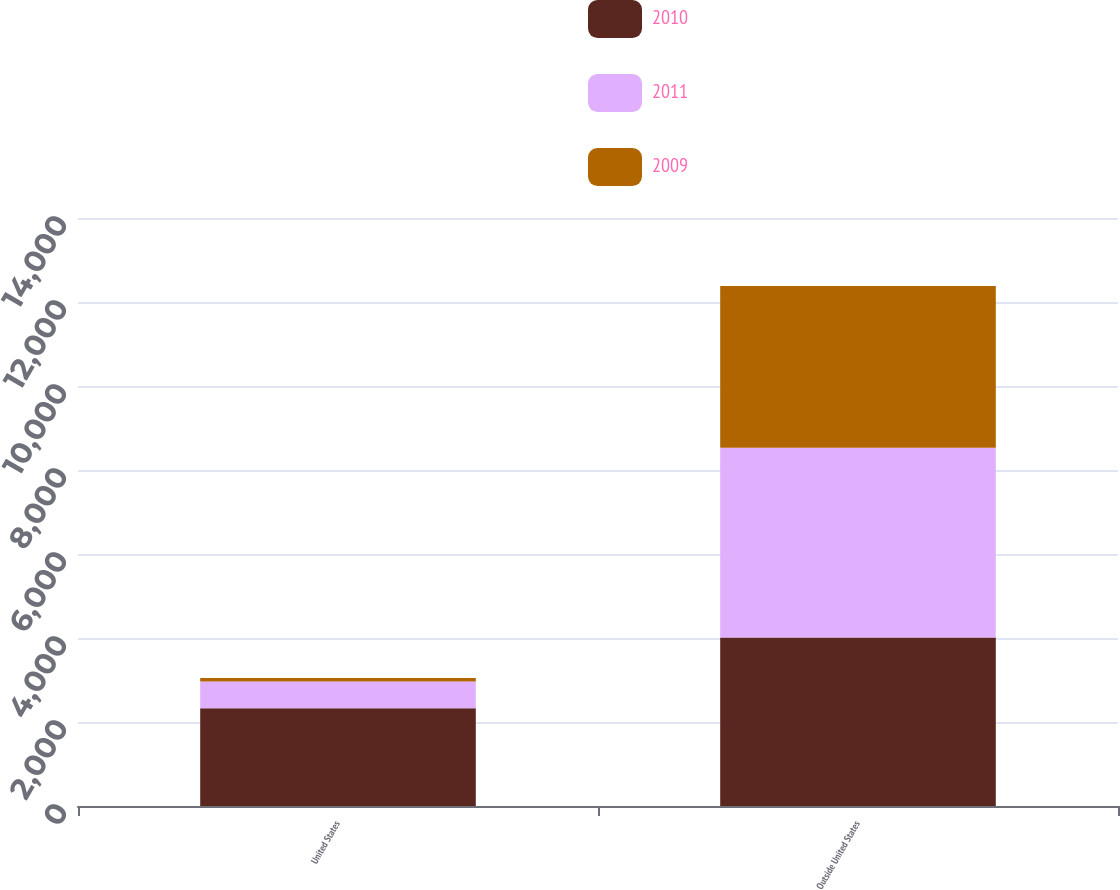<chart> <loc_0><loc_0><loc_500><loc_500><stacked_bar_chart><ecel><fcel>United States<fcel>Outside United States<nl><fcel>2010<fcel>2325<fcel>4013<nl><fcel>2011<fcel>638<fcel>4518<nl><fcel>2009<fcel>86<fcel>3848<nl></chart> 